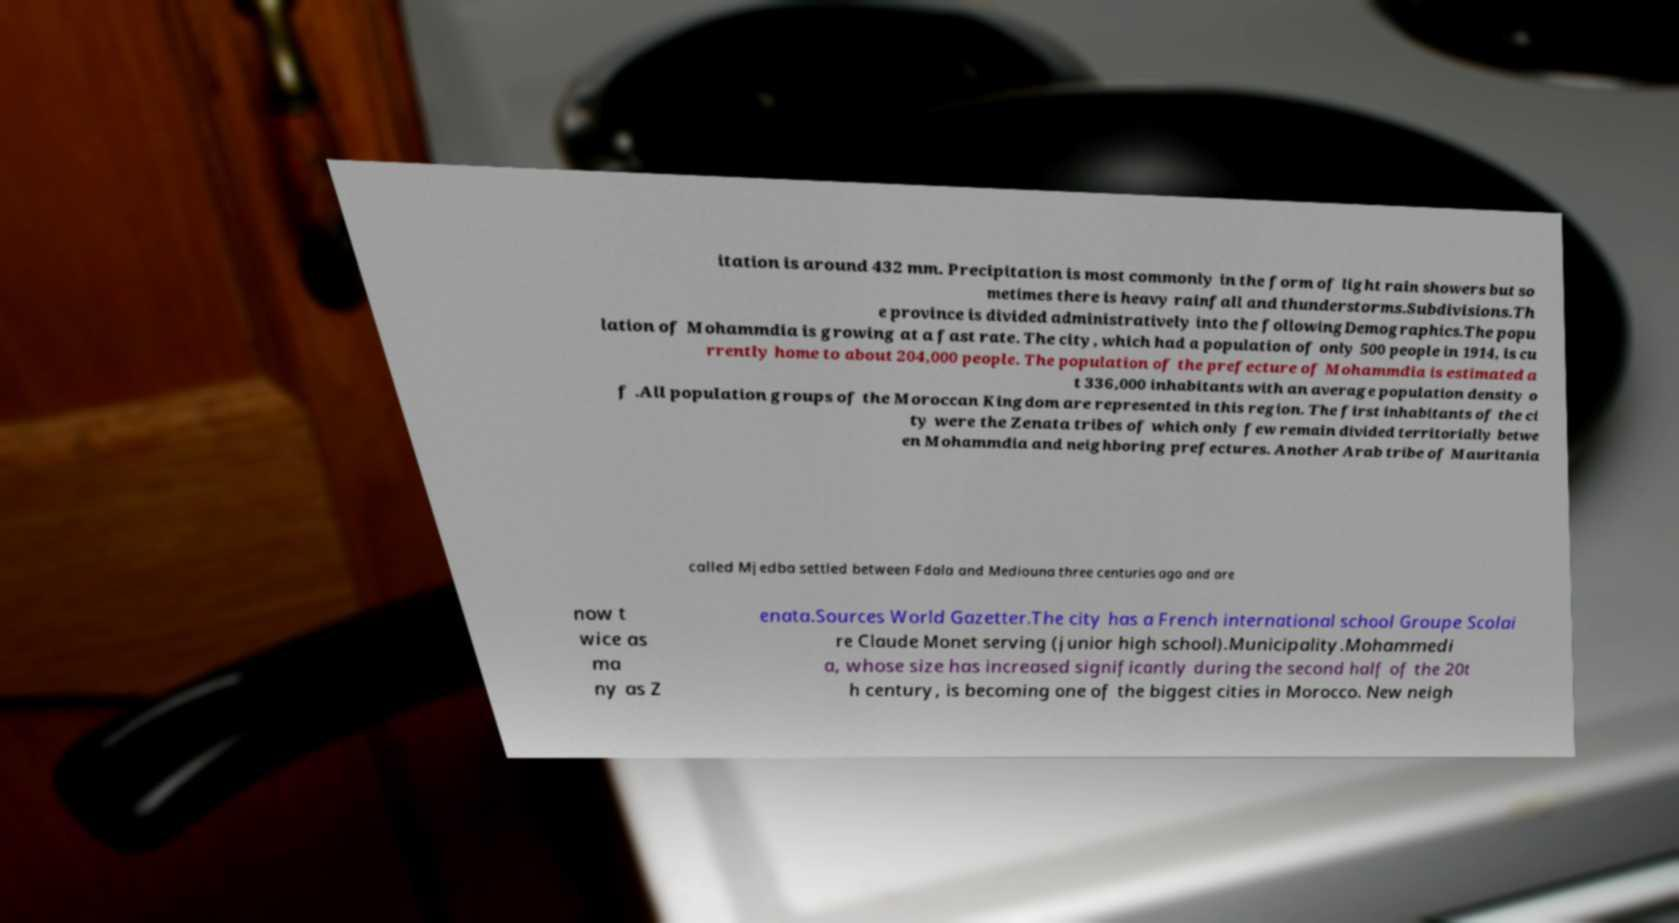I need the written content from this picture converted into text. Can you do that? itation is around 432 mm. Precipitation is most commonly in the form of light rain showers but so metimes there is heavy rainfall and thunderstorms.Subdivisions.Th e province is divided administratively into the followingDemographics.The popu lation of Mohammdia is growing at a fast rate. The city, which had a population of only 500 people in 1914, is cu rrently home to about 204,000 people. The population of the prefecture of Mohammdia is estimated a t 336,000 inhabitants with an average population density o f .All population groups of the Moroccan Kingdom are represented in this region. The first inhabitants of the ci ty were the Zenata tribes of which only few remain divided territorially betwe en Mohammdia and neighboring prefectures. Another Arab tribe of Mauritania called Mjedba settled between Fdala and Mediouna three centuries ago and are now t wice as ma ny as Z enata.Sources World Gazetter.The city has a French international school Groupe Scolai re Claude Monet serving (junior high school).Municipality.Mohammedi a, whose size has increased significantly during the second half of the 20t h century, is becoming one of the biggest cities in Morocco. New neigh 